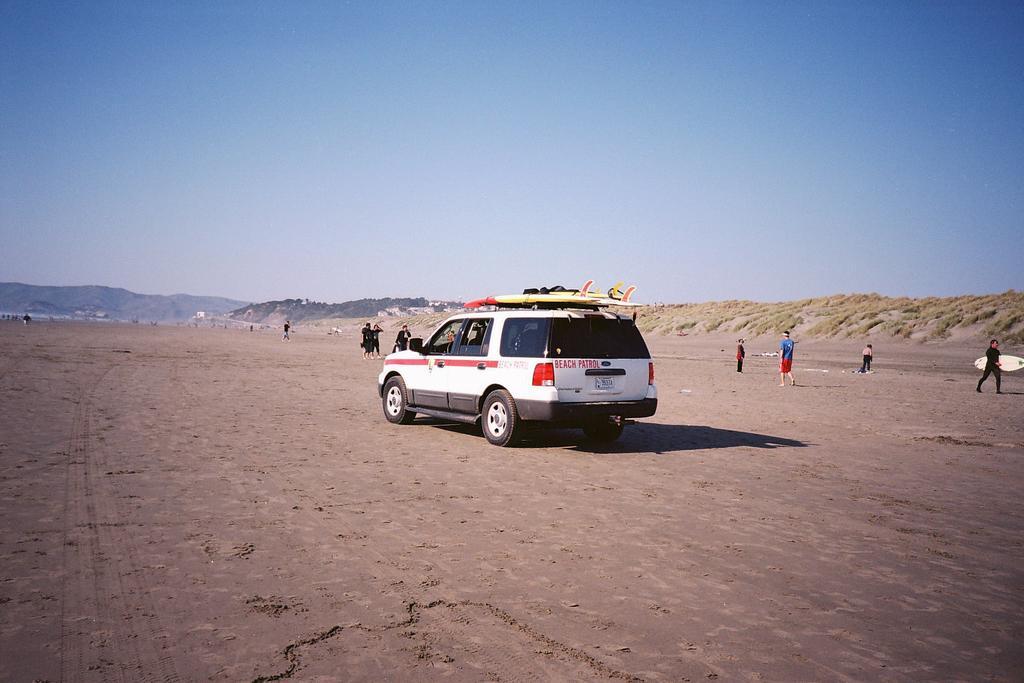Can you describe this image briefly? In this picture we can see a vehicle and people on the ground, one person is holding a surfboard and in the background we can see mountains, sky. 